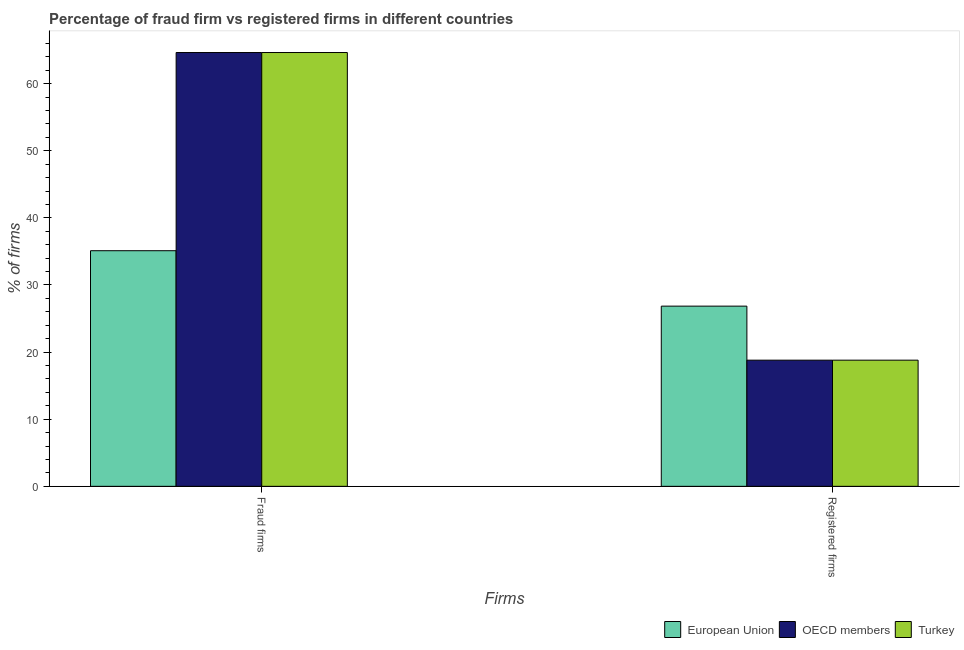How many different coloured bars are there?
Your answer should be compact. 3. How many groups of bars are there?
Provide a succinct answer. 2. Are the number of bars per tick equal to the number of legend labels?
Provide a short and direct response. Yes. How many bars are there on the 2nd tick from the left?
Provide a short and direct response. 3. How many bars are there on the 1st tick from the right?
Provide a succinct answer. 3. What is the label of the 1st group of bars from the left?
Your answer should be very brief. Fraud firms. What is the percentage of registered firms in European Union?
Keep it short and to the point. 26.85. Across all countries, what is the maximum percentage of fraud firms?
Your answer should be very brief. 64.64. Across all countries, what is the minimum percentage of registered firms?
Offer a very short reply. 18.8. In which country was the percentage of fraud firms minimum?
Keep it short and to the point. European Union. What is the total percentage of registered firms in the graph?
Provide a short and direct response. 64.45. What is the difference between the percentage of fraud firms in OECD members and that in European Union?
Offer a very short reply. 29.53. What is the difference between the percentage of registered firms in OECD members and the percentage of fraud firms in Turkey?
Keep it short and to the point. -45.84. What is the average percentage of registered firms per country?
Offer a very short reply. 21.48. What is the difference between the percentage of registered firms and percentage of fraud firms in Turkey?
Ensure brevity in your answer.  -45.84. What is the ratio of the percentage of fraud firms in Turkey to that in European Union?
Provide a succinct answer. 1.84. In how many countries, is the percentage of fraud firms greater than the average percentage of fraud firms taken over all countries?
Provide a succinct answer. 2. What does the 3rd bar from the left in Registered firms represents?
Your response must be concise. Turkey. How many bars are there?
Ensure brevity in your answer.  6. Does the graph contain any zero values?
Offer a terse response. No. How many legend labels are there?
Offer a very short reply. 3. What is the title of the graph?
Make the answer very short. Percentage of fraud firm vs registered firms in different countries. What is the label or title of the X-axis?
Offer a terse response. Firms. What is the label or title of the Y-axis?
Your answer should be compact. % of firms. What is the % of firms of European Union in Fraud firms?
Make the answer very short. 35.11. What is the % of firms in OECD members in Fraud firms?
Provide a short and direct response. 64.64. What is the % of firms of Turkey in Fraud firms?
Offer a very short reply. 64.64. What is the % of firms in European Union in Registered firms?
Offer a very short reply. 26.85. What is the % of firms in OECD members in Registered firms?
Your answer should be compact. 18.8. What is the % of firms of Turkey in Registered firms?
Ensure brevity in your answer.  18.8. Across all Firms, what is the maximum % of firms of European Union?
Your answer should be compact. 35.11. Across all Firms, what is the maximum % of firms of OECD members?
Provide a succinct answer. 64.64. Across all Firms, what is the maximum % of firms of Turkey?
Offer a very short reply. 64.64. Across all Firms, what is the minimum % of firms of European Union?
Ensure brevity in your answer.  26.85. What is the total % of firms of European Union in the graph?
Give a very brief answer. 61.96. What is the total % of firms in OECD members in the graph?
Ensure brevity in your answer.  83.44. What is the total % of firms in Turkey in the graph?
Ensure brevity in your answer.  83.44. What is the difference between the % of firms of European Union in Fraud firms and that in Registered firms?
Offer a terse response. 8.26. What is the difference between the % of firms in OECD members in Fraud firms and that in Registered firms?
Make the answer very short. 45.84. What is the difference between the % of firms in Turkey in Fraud firms and that in Registered firms?
Provide a succinct answer. 45.84. What is the difference between the % of firms of European Union in Fraud firms and the % of firms of OECD members in Registered firms?
Give a very brief answer. 16.31. What is the difference between the % of firms in European Union in Fraud firms and the % of firms in Turkey in Registered firms?
Ensure brevity in your answer.  16.31. What is the difference between the % of firms of OECD members in Fraud firms and the % of firms of Turkey in Registered firms?
Your response must be concise. 45.84. What is the average % of firms of European Union per Firms?
Give a very brief answer. 30.98. What is the average % of firms of OECD members per Firms?
Your response must be concise. 41.72. What is the average % of firms in Turkey per Firms?
Offer a very short reply. 41.72. What is the difference between the % of firms of European Union and % of firms of OECD members in Fraud firms?
Provide a short and direct response. -29.53. What is the difference between the % of firms in European Union and % of firms in Turkey in Fraud firms?
Your answer should be very brief. -29.53. What is the difference between the % of firms in OECD members and % of firms in Turkey in Fraud firms?
Ensure brevity in your answer.  0. What is the difference between the % of firms of European Union and % of firms of OECD members in Registered firms?
Your answer should be compact. 8.05. What is the difference between the % of firms of European Union and % of firms of Turkey in Registered firms?
Offer a very short reply. 8.05. What is the difference between the % of firms in OECD members and % of firms in Turkey in Registered firms?
Ensure brevity in your answer.  0. What is the ratio of the % of firms in European Union in Fraud firms to that in Registered firms?
Your answer should be very brief. 1.31. What is the ratio of the % of firms of OECD members in Fraud firms to that in Registered firms?
Your answer should be compact. 3.44. What is the ratio of the % of firms of Turkey in Fraud firms to that in Registered firms?
Ensure brevity in your answer.  3.44. What is the difference between the highest and the second highest % of firms in European Union?
Provide a short and direct response. 8.26. What is the difference between the highest and the second highest % of firms in OECD members?
Your answer should be very brief. 45.84. What is the difference between the highest and the second highest % of firms of Turkey?
Make the answer very short. 45.84. What is the difference between the highest and the lowest % of firms in European Union?
Your answer should be very brief. 8.26. What is the difference between the highest and the lowest % of firms of OECD members?
Offer a very short reply. 45.84. What is the difference between the highest and the lowest % of firms of Turkey?
Offer a very short reply. 45.84. 